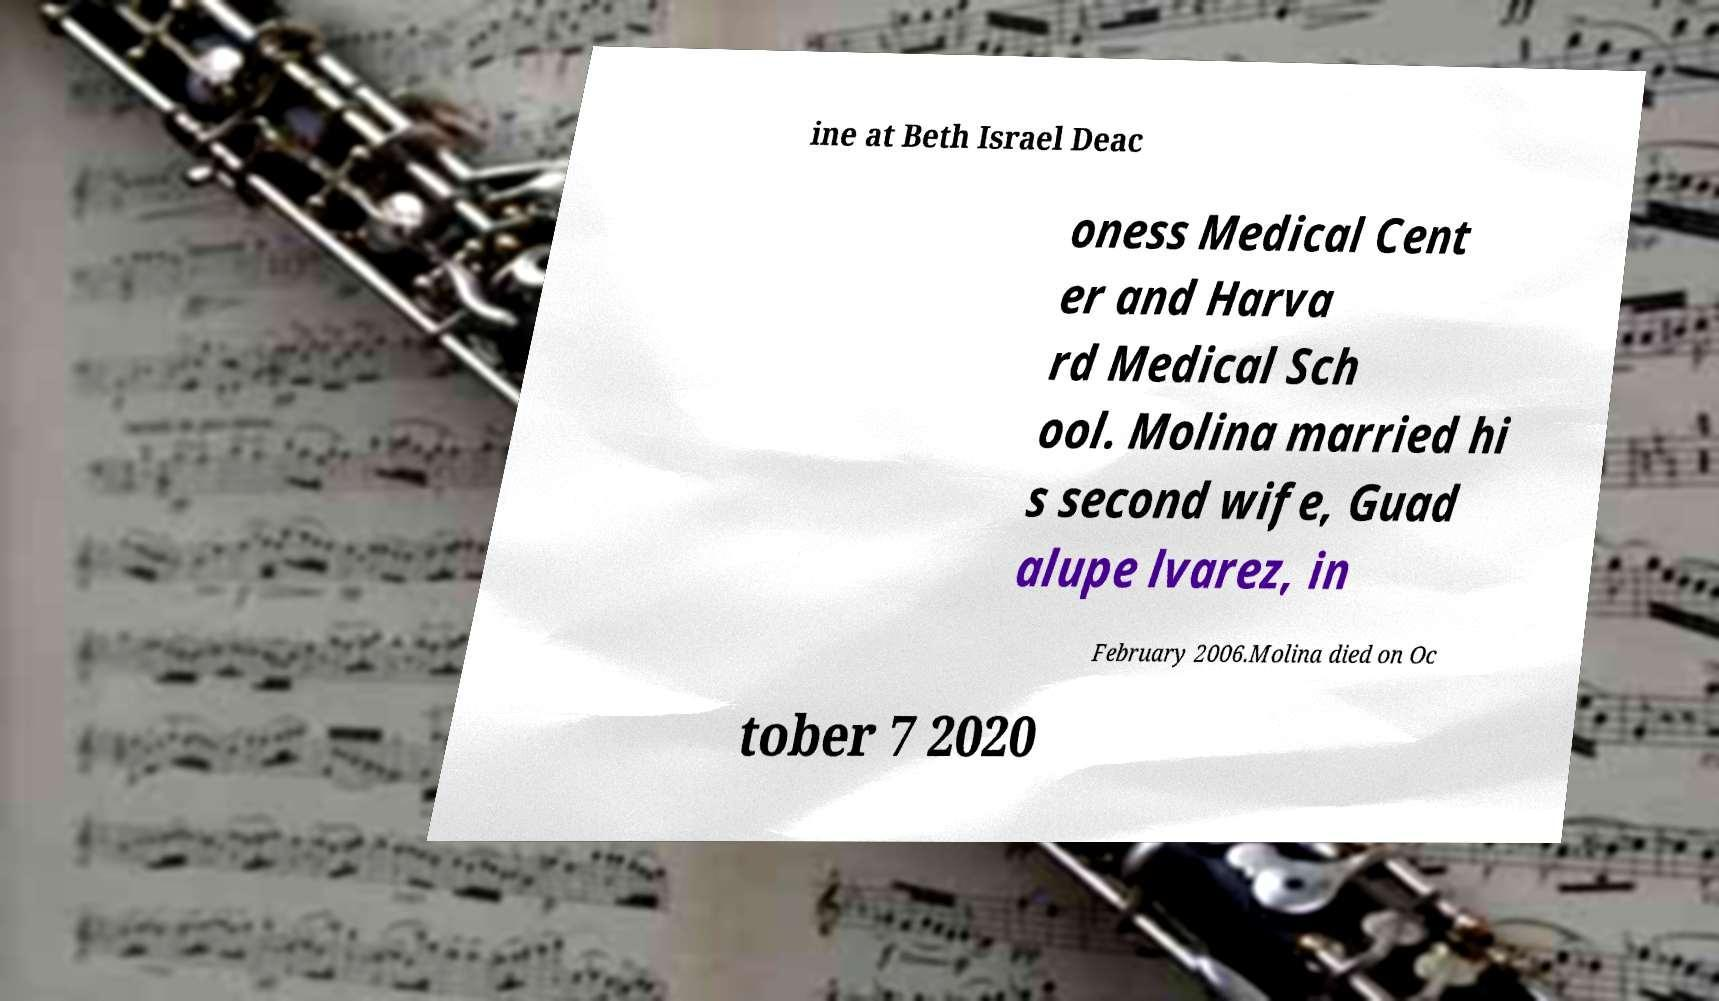Could you extract and type out the text from this image? ine at Beth Israel Deac oness Medical Cent er and Harva rd Medical Sch ool. Molina married hi s second wife, Guad alupe lvarez, in February 2006.Molina died on Oc tober 7 2020 